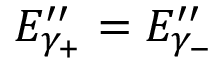Convert formula to latex. <formula><loc_0><loc_0><loc_500><loc_500>E _ { \gamma _ { + } } ^ { \prime \prime } = E _ { \gamma _ { - } } ^ { \prime \prime }</formula> 